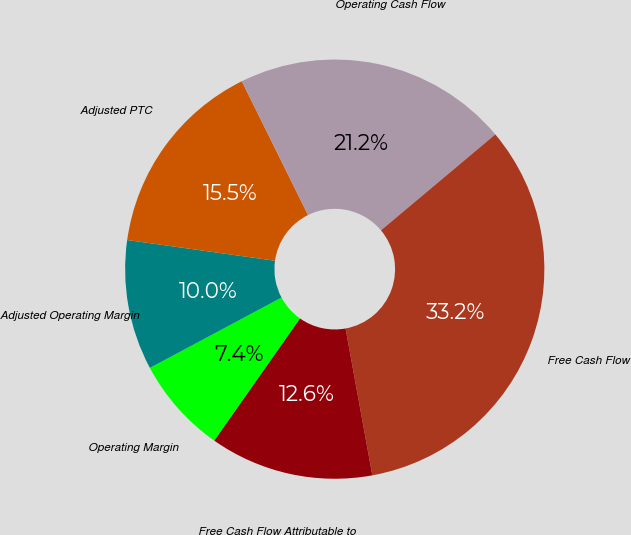Convert chart to OTSL. <chart><loc_0><loc_0><loc_500><loc_500><pie_chart><fcel>Operating Margin<fcel>Adjusted Operating Margin<fcel>Adjusted PTC<fcel>Operating Cash Flow<fcel>Free Cash Flow<fcel>Free Cash Flow Attributable to<nl><fcel>7.45%<fcel>10.03%<fcel>15.47%<fcel>21.2%<fcel>33.24%<fcel>12.61%<nl></chart> 